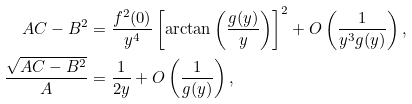<formula> <loc_0><loc_0><loc_500><loc_500>A C - B ^ { 2 } & = \frac { f ^ { 2 } ( 0 ) } { y ^ { 4 } } \left [ \arctan { \left ( \frac { g ( y ) } { y } \right ) } \right ] ^ { 2 } + O \left ( \frac { 1 } { y ^ { 3 } g ( y ) } \right ) , \\ \frac { \sqrt { A C - B ^ { 2 } } } { A } & = \frac { 1 } { 2 y } + O \left ( \frac { 1 } { g ( y ) } \right ) ,</formula> 